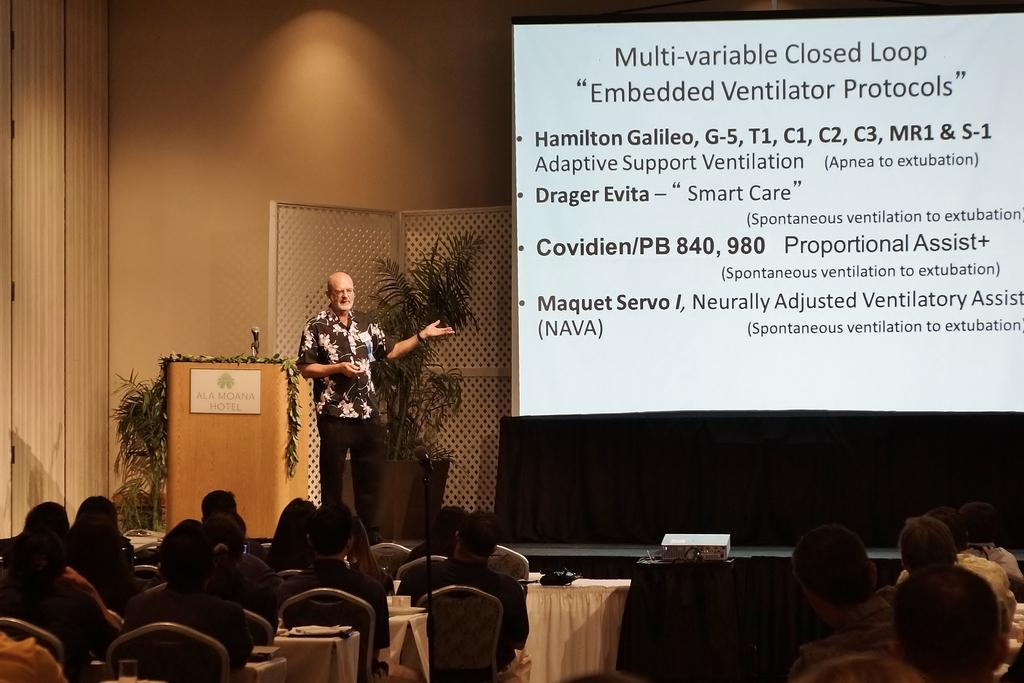Who or what can be seen in the image? There are people in the image. What objects are present for seating? There are chairs in the image. What type of vegetation is visible? There are plants in the image. What is on the right side of the image? There is a screen on the right side of the image. What is written or displayed on the screen? There is something written on the screen. What color is the wall behind the screen? The wall behind the screen is orange in color. Can you tell me where the boundary between the two countries is located in the image? There is no information about any boundaries or countries in the image; it features people, chairs, plants, a screen, and an orange wall. Is there a stream visible in the image? No, there is no stream present in the image. 